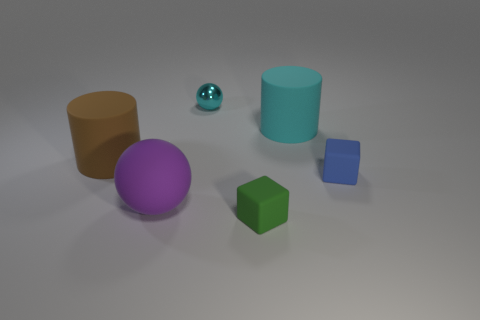Add 2 tiny cyan matte things. How many objects exist? 8 Subtract all spheres. How many objects are left? 4 Subtract 1 purple spheres. How many objects are left? 5 Subtract all blue things. Subtract all rubber cylinders. How many objects are left? 3 Add 2 balls. How many balls are left? 4 Add 3 cyan matte things. How many cyan matte things exist? 4 